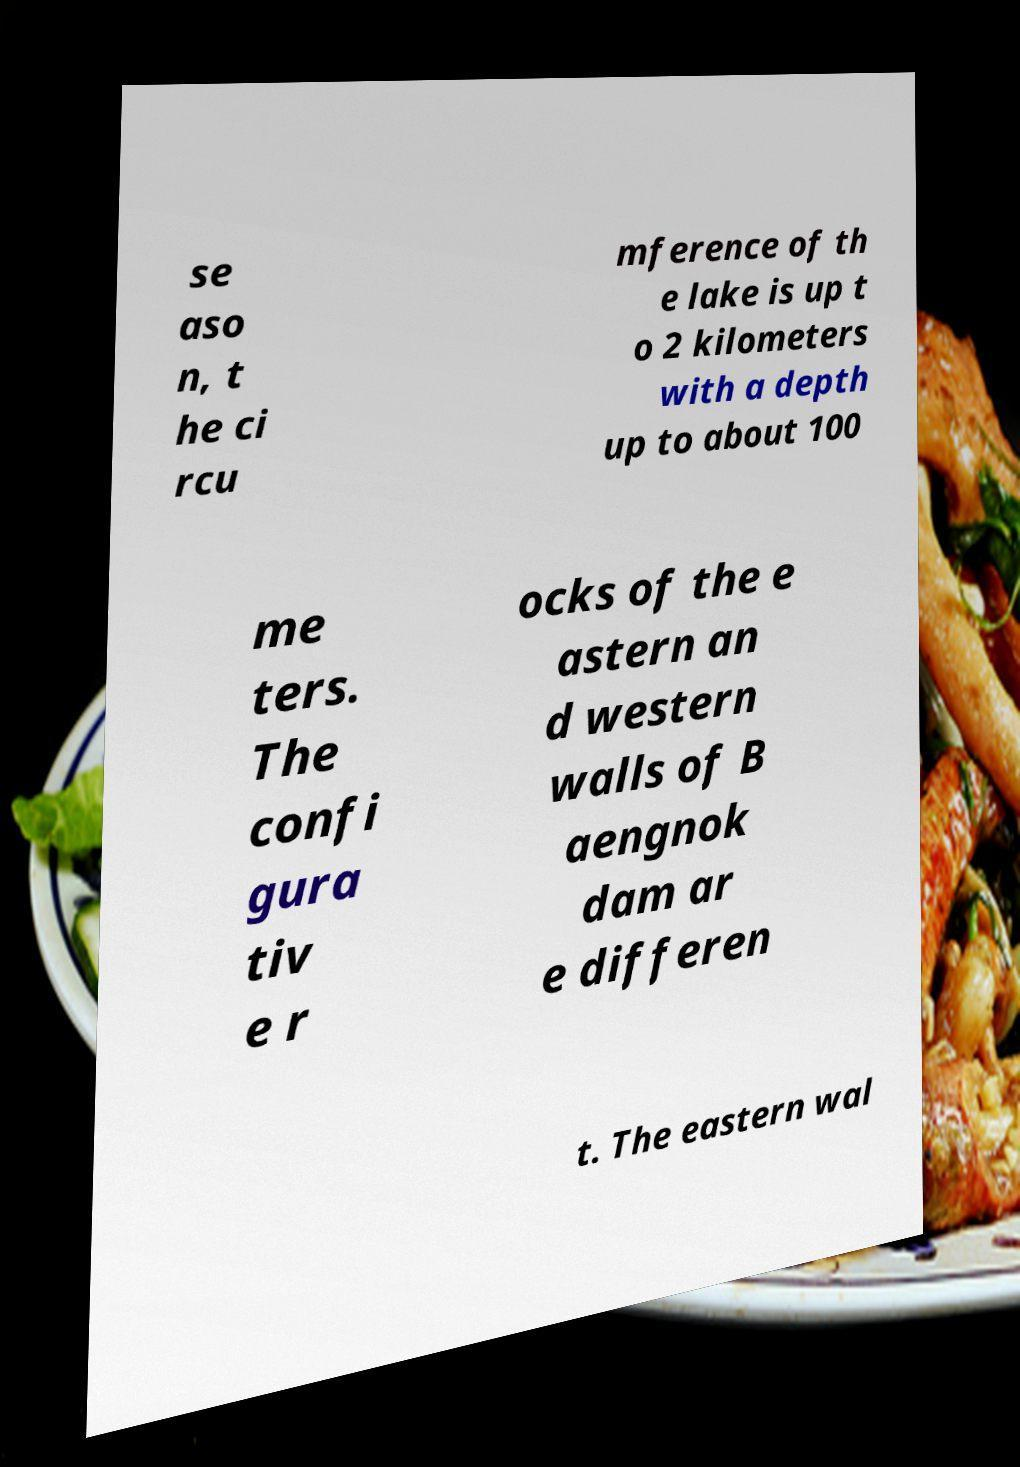Please read and relay the text visible in this image. What does it say? se aso n, t he ci rcu mference of th e lake is up t o 2 kilometers with a depth up to about 100 me ters. The confi gura tiv e r ocks of the e astern an d western walls of B aengnok dam ar e differen t. The eastern wal 